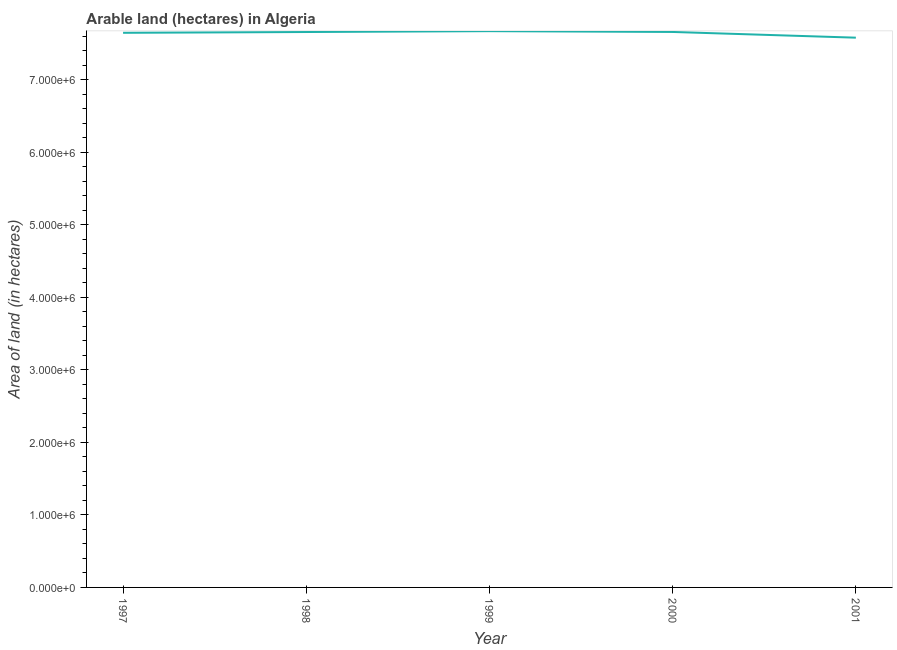What is the area of land in 1999?
Give a very brief answer. 7.67e+06. Across all years, what is the maximum area of land?
Offer a very short reply. 7.67e+06. Across all years, what is the minimum area of land?
Make the answer very short. 7.58e+06. In which year was the area of land maximum?
Offer a terse response. 1999. In which year was the area of land minimum?
Offer a very short reply. 2001. What is the sum of the area of land?
Give a very brief answer. 3.82e+07. What is the difference between the area of land in 1997 and 1998?
Your answer should be compact. -1.10e+04. What is the average area of land per year?
Your answer should be compact. 7.65e+06. What is the median area of land?
Your answer should be very brief. 7.66e+06. Do a majority of the years between 1999 and 2000 (inclusive) have area of land greater than 5600000 hectares?
Your response must be concise. Yes. What is the ratio of the area of land in 2000 to that in 2001?
Offer a terse response. 1.01. Is the area of land in 1998 less than that in 2001?
Give a very brief answer. No. Is the difference between the area of land in 1997 and 2001 greater than the difference between any two years?
Make the answer very short. No. What is the difference between the highest and the second highest area of land?
Offer a terse response. 1.10e+04. What is the difference between the highest and the lowest area of land?
Offer a very short reply. 9.00e+04. In how many years, is the area of land greater than the average area of land taken over all years?
Ensure brevity in your answer.  4. Does the area of land monotonically increase over the years?
Your response must be concise. No. How many lines are there?
Offer a very short reply. 1. How many years are there in the graph?
Provide a short and direct response. 5. Does the graph contain grids?
Give a very brief answer. No. What is the title of the graph?
Keep it short and to the point. Arable land (hectares) in Algeria. What is the label or title of the Y-axis?
Give a very brief answer. Area of land (in hectares). What is the Area of land (in hectares) of 1997?
Keep it short and to the point. 7.65e+06. What is the Area of land (in hectares) in 1998?
Provide a succinct answer. 7.66e+06. What is the Area of land (in hectares) of 1999?
Offer a terse response. 7.67e+06. What is the Area of land (in hectares) of 2000?
Your response must be concise. 7.66e+06. What is the Area of land (in hectares) of 2001?
Provide a succinct answer. 7.58e+06. What is the difference between the Area of land (in hectares) in 1997 and 1998?
Give a very brief answer. -1.10e+04. What is the difference between the Area of land (in hectares) in 1997 and 1999?
Offer a terse response. -2.30e+04. What is the difference between the Area of land (in hectares) in 1997 and 2000?
Provide a succinct answer. -1.20e+04. What is the difference between the Area of land (in hectares) in 1997 and 2001?
Give a very brief answer. 6.70e+04. What is the difference between the Area of land (in hectares) in 1998 and 1999?
Provide a succinct answer. -1.20e+04. What is the difference between the Area of land (in hectares) in 1998 and 2000?
Your response must be concise. -1000. What is the difference between the Area of land (in hectares) in 1998 and 2001?
Ensure brevity in your answer.  7.80e+04. What is the difference between the Area of land (in hectares) in 1999 and 2000?
Make the answer very short. 1.10e+04. What is the difference between the Area of land (in hectares) in 2000 and 2001?
Your answer should be very brief. 7.90e+04. What is the ratio of the Area of land (in hectares) in 1997 to that in 1998?
Provide a short and direct response. 1. What is the ratio of the Area of land (in hectares) in 1997 to that in 2000?
Your answer should be very brief. 1. What is the ratio of the Area of land (in hectares) in 1998 to that in 2001?
Give a very brief answer. 1.01. What is the ratio of the Area of land (in hectares) in 1999 to that in 2001?
Your answer should be very brief. 1.01. What is the ratio of the Area of land (in hectares) in 2000 to that in 2001?
Keep it short and to the point. 1.01. 